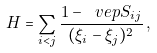Convert formula to latex. <formula><loc_0><loc_0><loc_500><loc_500>H = \sum _ { i < j } \frac { 1 - \ v e p S _ { i j } } { ( \xi _ { i } - \xi _ { j } ) ^ { 2 } } \, ,</formula> 